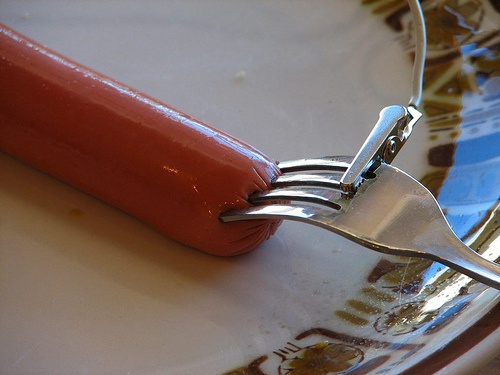Describe the objects in this image and their specific colors. I can see hot dog in gray, maroon, brown, and darkgray tones and fork in gray tones in this image. 